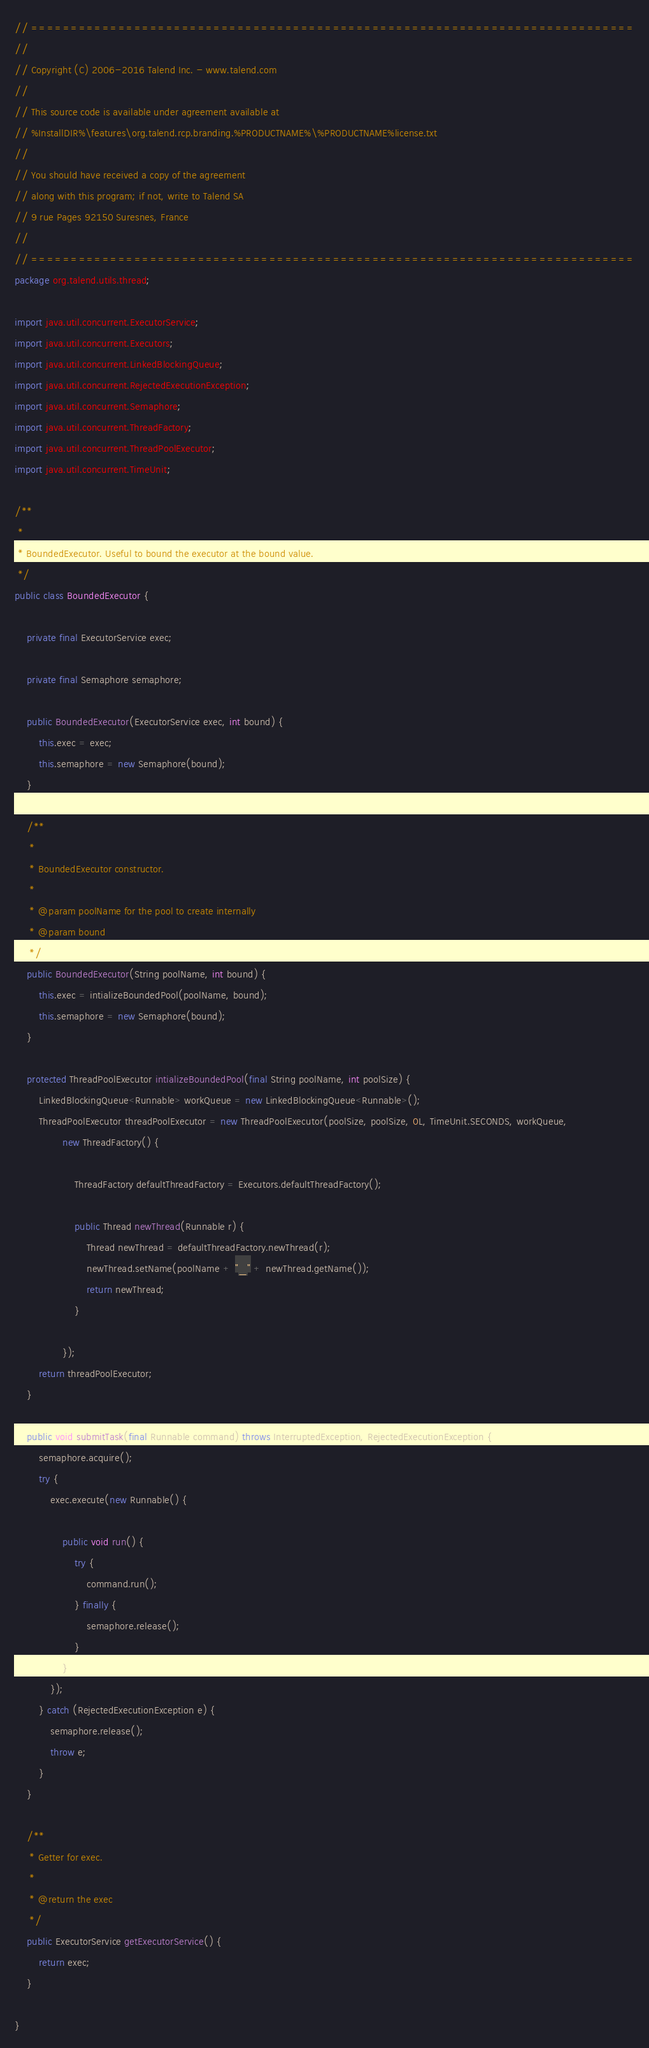Convert code to text. <code><loc_0><loc_0><loc_500><loc_500><_Java_>// ============================================================================
//
// Copyright (C) 2006-2016 Talend Inc. - www.talend.com
//
// This source code is available under agreement available at
// %InstallDIR%\features\org.talend.rcp.branding.%PRODUCTNAME%\%PRODUCTNAME%license.txt
//
// You should have received a copy of the agreement
// along with this program; if not, write to Talend SA
// 9 rue Pages 92150 Suresnes, France
//
// ============================================================================
package org.talend.utils.thread;

import java.util.concurrent.ExecutorService;
import java.util.concurrent.Executors;
import java.util.concurrent.LinkedBlockingQueue;
import java.util.concurrent.RejectedExecutionException;
import java.util.concurrent.Semaphore;
import java.util.concurrent.ThreadFactory;
import java.util.concurrent.ThreadPoolExecutor;
import java.util.concurrent.TimeUnit;

/**
 * 
 * BoundedExecutor. Useful to bound the executor at the bound value.
 */
public class BoundedExecutor {

    private final ExecutorService exec;

    private final Semaphore semaphore;

    public BoundedExecutor(ExecutorService exec, int bound) {
        this.exec = exec;
        this.semaphore = new Semaphore(bound);
    }

    /**
     * 
     * BoundedExecutor constructor.
     * 
     * @param poolName for the pool to create internally
     * @param bound
     */
    public BoundedExecutor(String poolName, int bound) {
        this.exec = intializeBoundedPool(poolName, bound);
        this.semaphore = new Semaphore(bound);
    }

    protected ThreadPoolExecutor intializeBoundedPool(final String poolName, int poolSize) {
        LinkedBlockingQueue<Runnable> workQueue = new LinkedBlockingQueue<Runnable>();
        ThreadPoolExecutor threadPoolExecutor = new ThreadPoolExecutor(poolSize, poolSize, 0L, TimeUnit.SECONDS, workQueue,
                new ThreadFactory() {

                    ThreadFactory defaultThreadFactory = Executors.defaultThreadFactory();

                    public Thread newThread(Runnable r) {
                        Thread newThread = defaultThreadFactory.newThread(r);
                        newThread.setName(poolName + "_" + newThread.getName());
                        return newThread;
                    }

                });
        return threadPoolExecutor;
    }

    public void submitTask(final Runnable command) throws InterruptedException, RejectedExecutionException {
        semaphore.acquire();
        try {
            exec.execute(new Runnable() {

                public void run() {
                    try {
                        command.run();
                    } finally {
                        semaphore.release();
                    }
                }
            });
        } catch (RejectedExecutionException e) {
            semaphore.release();
            throw e;
        }
    }

    /**
     * Getter for exec.
     * 
     * @return the exec
     */
    public ExecutorService getExecutorService() {
        return exec;
    }

}
</code> 